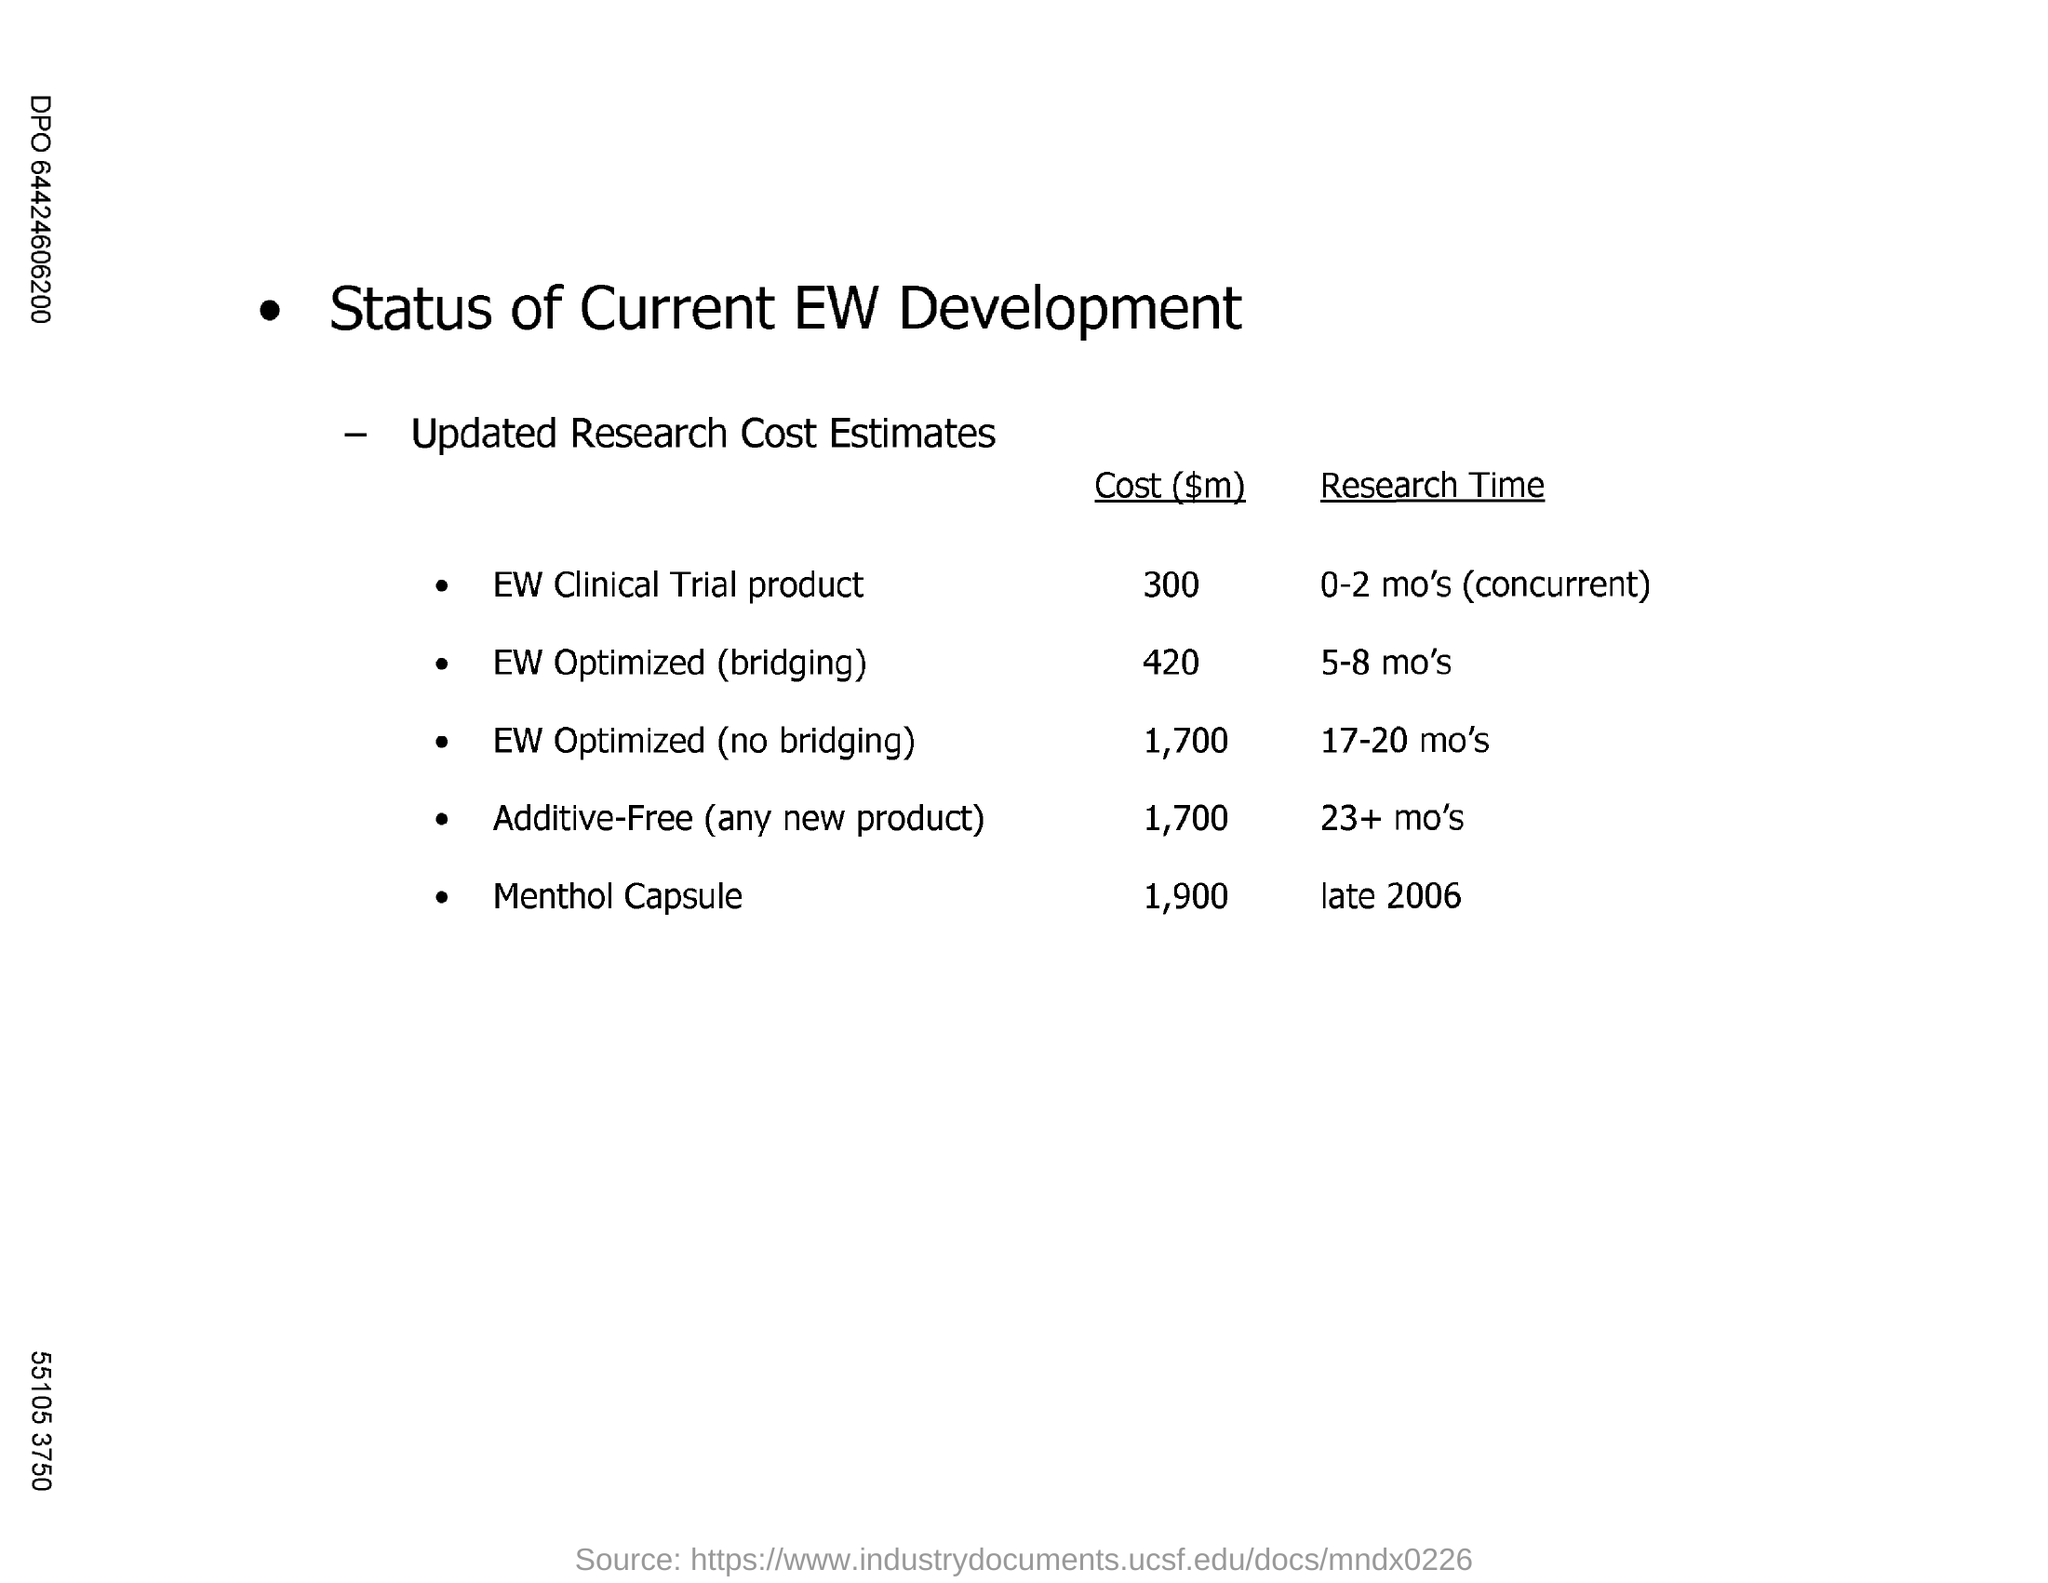Draw attention to some important aspects in this diagram. The research time for the EW clinical trial product is expected to be approximately 0-2 months, with concurrent research activities. The research on menthol capsules was conducted in late 2006. The cost for Menthol Capsule is 1,900. The cost for the EW Clinical Trial Product is 300... 